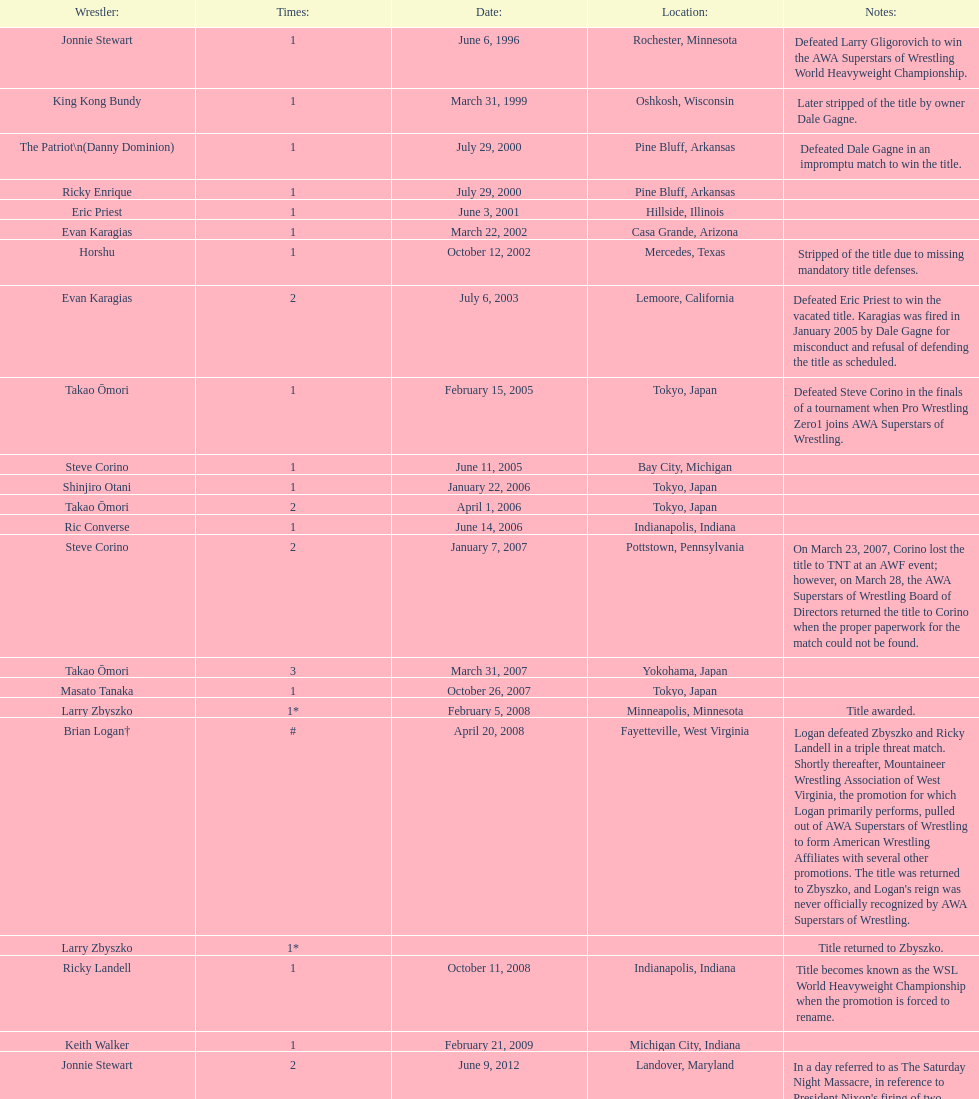Who was the previous titleholder that the patriot (danny dominion) defeated in an unexpected match to win the championship? Dale Gagne. 